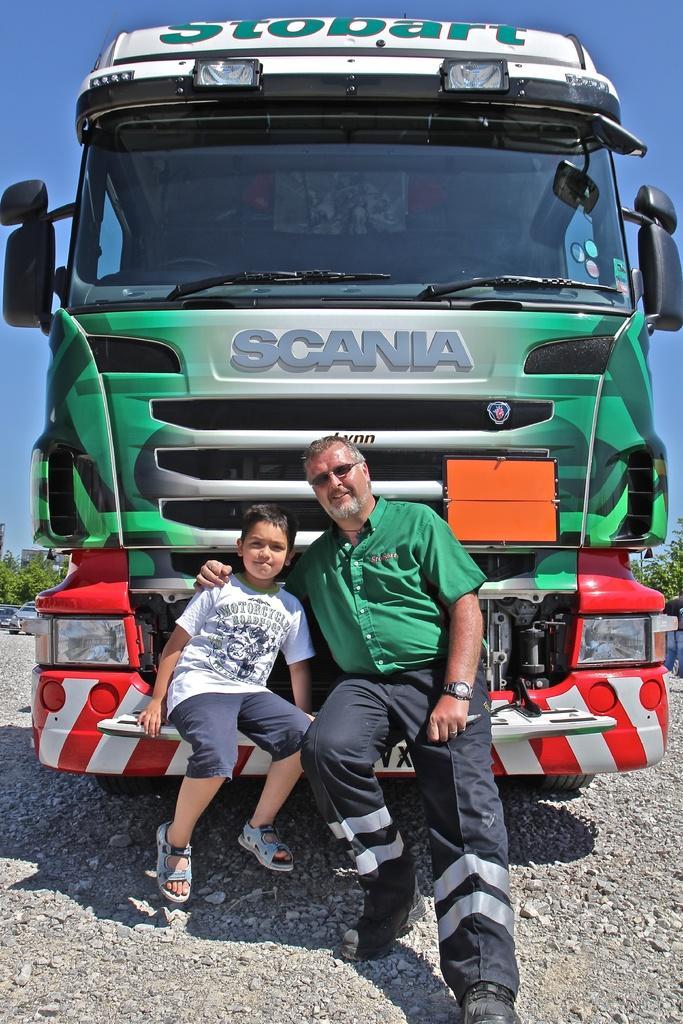How would you summarize this image in a sentence or two? In this image there is a person and a child sitting on the front part of a vehicle. In the background there are a few vehicles, trees, buildings and the sky. 